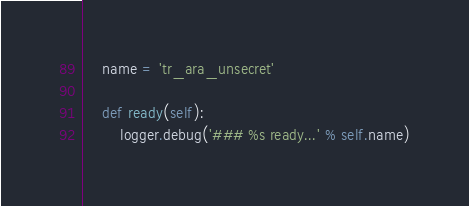<code> <loc_0><loc_0><loc_500><loc_500><_Python_>    name = 'tr_ara_unsecret'

    def ready(self):
        logger.debug('### %s ready...' % self.name)
</code> 